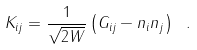<formula> <loc_0><loc_0><loc_500><loc_500>K _ { i j } = { \frac { 1 } { \sqrt { 2 W } } } \left ( G _ { i j } - n _ { i } n _ { j } \right ) \ .</formula> 